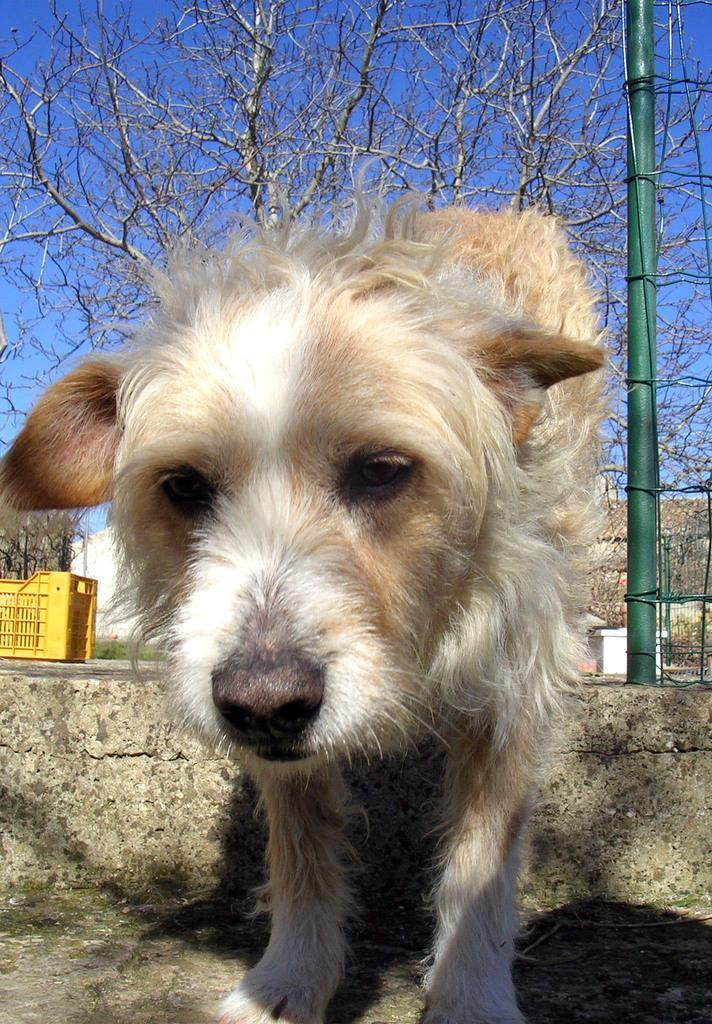Describe this image in one or two sentences. In this image there is a dog in the middle. In the background there is a tree. On the right side there is a green colour pole. On the left side there is a yellow colour tray on the wall. 